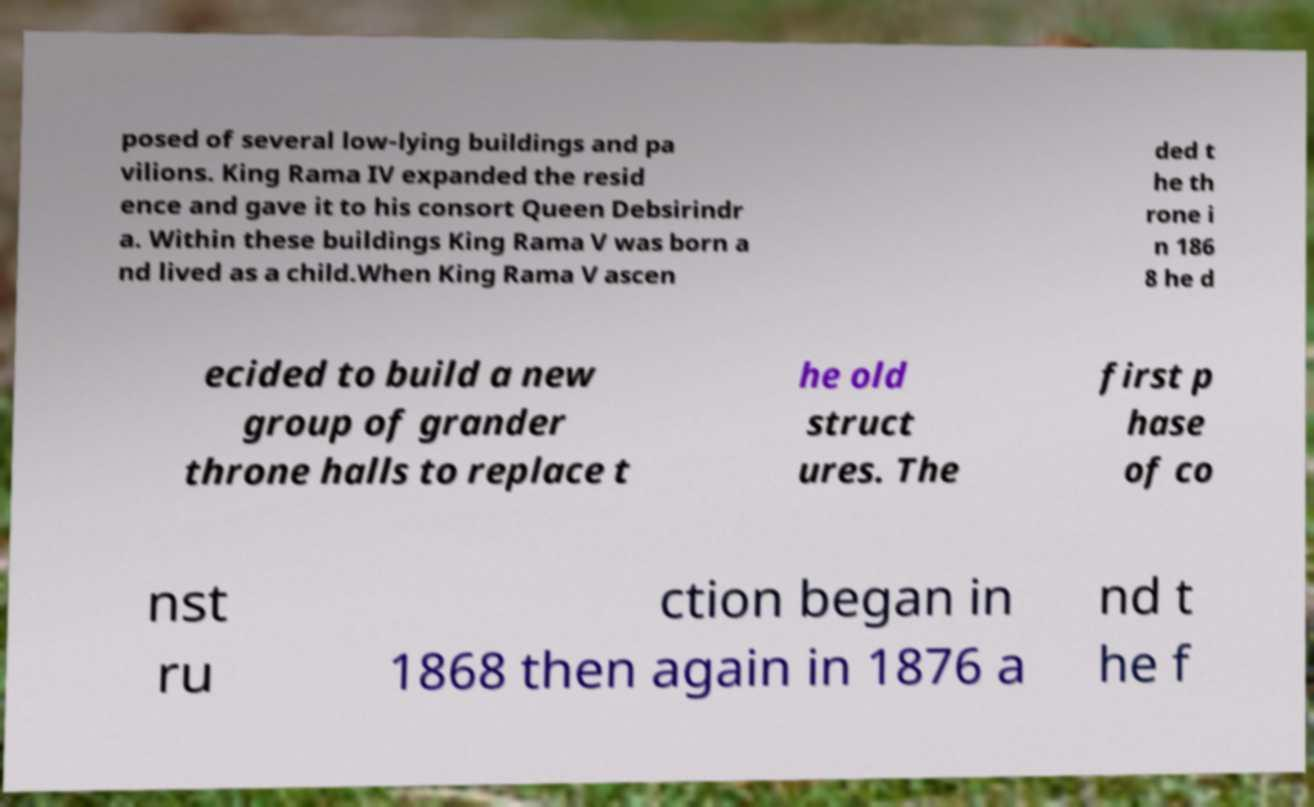Could you extract and type out the text from this image? posed of several low-lying buildings and pa vilions. King Rama IV expanded the resid ence and gave it to his consort Queen Debsirindr a. Within these buildings King Rama V was born a nd lived as a child.When King Rama V ascen ded t he th rone i n 186 8 he d ecided to build a new group of grander throne halls to replace t he old struct ures. The first p hase of co nst ru ction began in 1868 then again in 1876 a nd t he f 